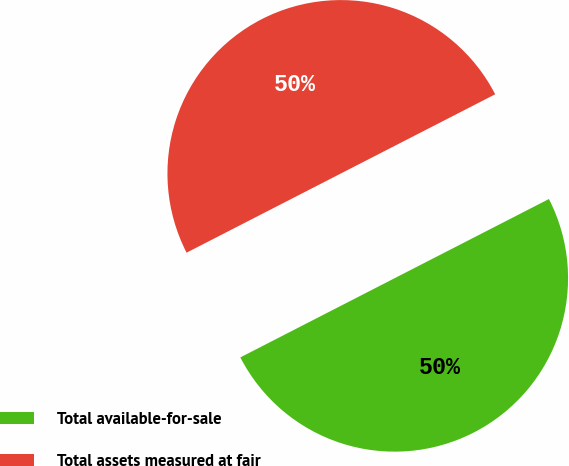Convert chart to OTSL. <chart><loc_0><loc_0><loc_500><loc_500><pie_chart><fcel>Total available-for-sale<fcel>Total assets measured at fair<nl><fcel>50.0%<fcel>50.0%<nl></chart> 